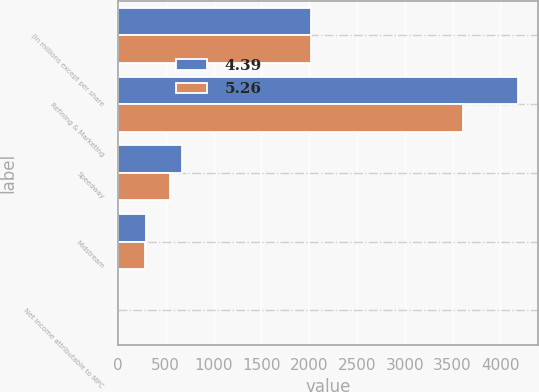<chart> <loc_0><loc_0><loc_500><loc_500><stacked_bar_chart><ecel><fcel>(In millions except per share<fcel>Refining & Marketing<fcel>Speedway<fcel>Midstream<fcel>Net income attributable to MPC<nl><fcel>4.39<fcel>2015<fcel>4186<fcel>673<fcel>289<fcel>5.26<nl><fcel>5.26<fcel>2014<fcel>3609<fcel>544<fcel>280<fcel>4.39<nl></chart> 